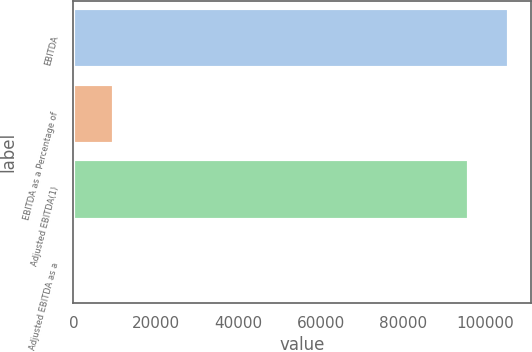Convert chart to OTSL. <chart><loc_0><loc_0><loc_500><loc_500><bar_chart><fcel>EBITDA<fcel>EBITDA as a Percentage of<fcel>Adjusted EBITDA(1)<fcel>Adjusted EBITDA as a<nl><fcel>105715<fcel>9759<fcel>95981<fcel>25<nl></chart> 